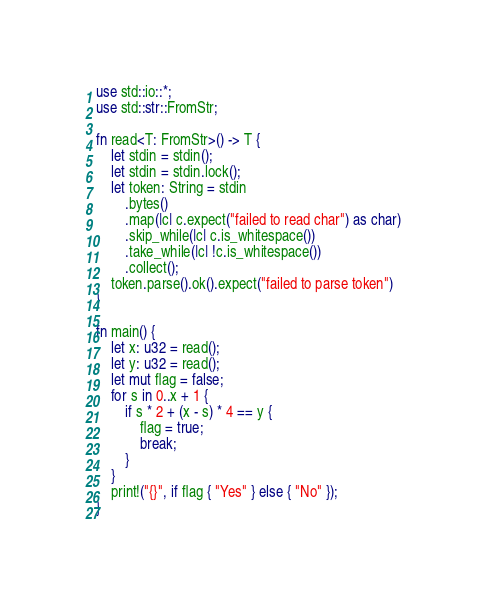Convert code to text. <code><loc_0><loc_0><loc_500><loc_500><_Rust_>use std::io::*;
use std::str::FromStr;

fn read<T: FromStr>() -> T {
    let stdin = stdin();
    let stdin = stdin.lock();
    let token: String = stdin
        .bytes()
        .map(|c| c.expect("failed to read char") as char)
        .skip_while(|c| c.is_whitespace())
        .take_while(|c| !c.is_whitespace())
        .collect();
    token.parse().ok().expect("failed to parse token")
}

fn main() {
    let x: u32 = read();
    let y: u32 = read();
    let mut flag = false;
    for s in 0..x + 1 {
        if s * 2 + (x - s) * 4 == y {
            flag = true;
            break;
        }
    }
    print!("{}", if flag { "Yes" } else { "No" });
}
</code> 